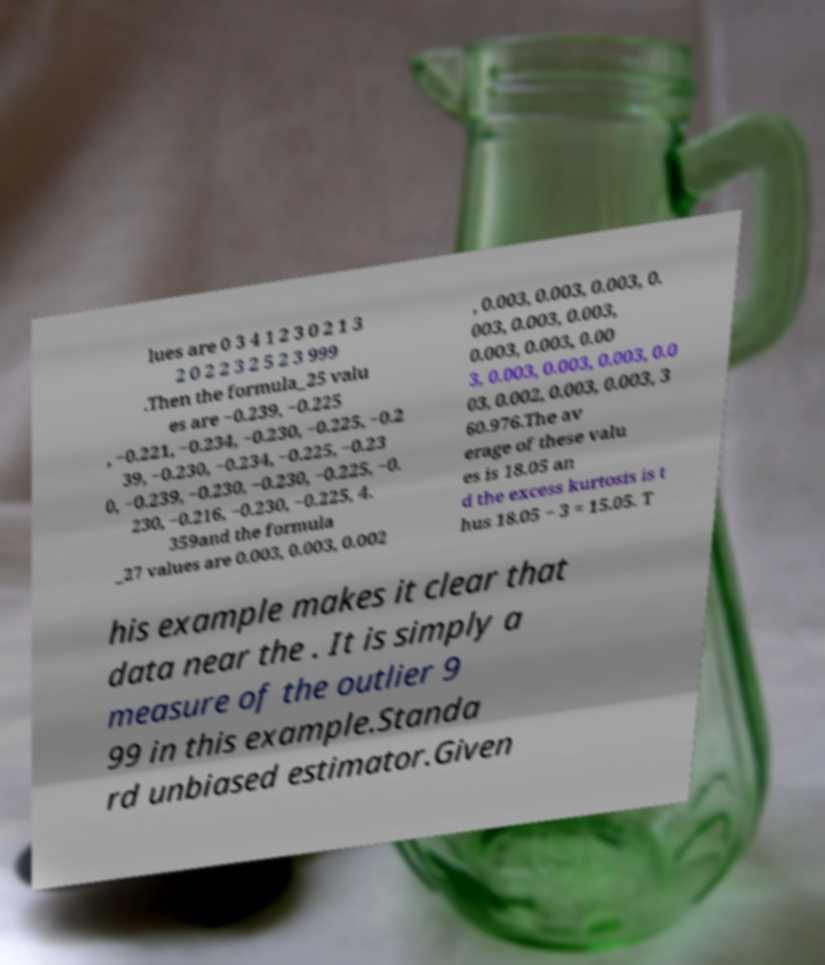I need the written content from this picture converted into text. Can you do that? lues are 0 3 4 1 2 3 0 2 1 3 2 0 2 2 3 2 5 2 3 999 .Then the formula_25 valu es are −0.239, −0.225 , −0.221, −0.234, −0.230, −0.225, −0.2 39, −0.230, −0.234, −0.225, −0.23 0, −0.239, −0.230, −0.230, −0.225, −0. 230, −0.216, −0.230, −0.225, 4. 359and the formula _27 values are 0.003, 0.003, 0.002 , 0.003, 0.003, 0.003, 0. 003, 0.003, 0.003, 0.003, 0.003, 0.00 3, 0.003, 0.003, 0.003, 0.0 03, 0.002, 0.003, 0.003, 3 60.976.The av erage of these valu es is 18.05 an d the excess kurtosis is t hus 18.05 − 3 = 15.05. T his example makes it clear that data near the . It is simply a measure of the outlier 9 99 in this example.Standa rd unbiased estimator.Given 